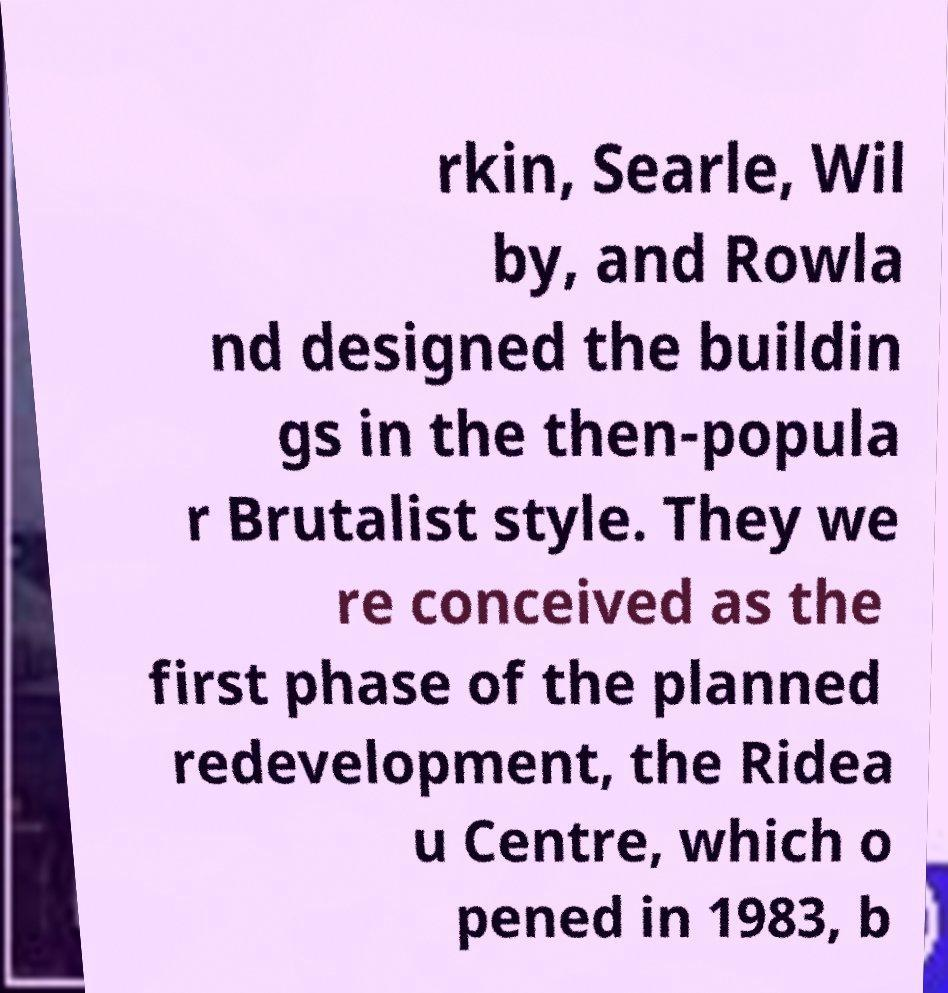Can you accurately transcribe the text from the provided image for me? rkin, Searle, Wil by, and Rowla nd designed the buildin gs in the then-popula r Brutalist style. They we re conceived as the first phase of the planned redevelopment, the Ridea u Centre, which o pened in 1983, b 